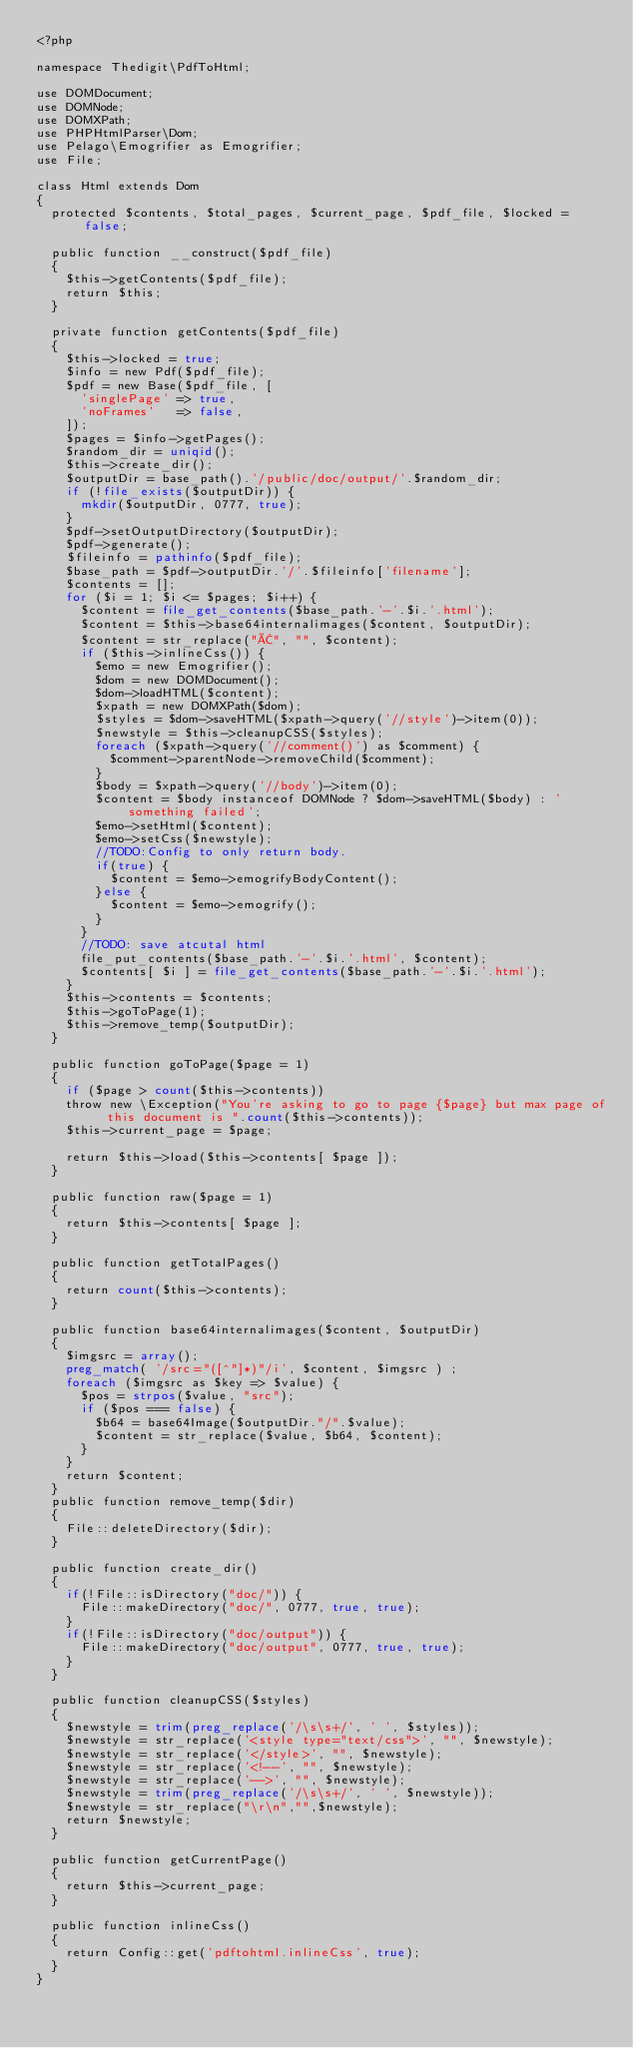<code> <loc_0><loc_0><loc_500><loc_500><_PHP_><?php

namespace Thedigit\PdfToHtml;

use DOMDocument;
use DOMNode;
use DOMXPath;
use PHPHtmlParser\Dom;
use Pelago\Emogrifier as Emogrifier;
use File;

class Html extends Dom
{
  protected $contents, $total_pages, $current_page, $pdf_file, $locked = false;

  public function __construct($pdf_file)
  {
    $this->getContents($pdf_file);
    return $this;
  }

  private function getContents($pdf_file)
  {
    $this->locked = true;
    $info = new Pdf($pdf_file);
    $pdf = new Base($pdf_file, [
      'singlePage' => true,
      'noFrames'   => false,
    ]);
    $pages = $info->getPages();
    $random_dir = uniqid();
    $this->create_dir();
    $outputDir = base_path().'/public/doc/output/'.$random_dir;
    if (!file_exists($outputDir)) {
      mkdir($outputDir, 0777, true);
    }
    $pdf->setOutputDirectory($outputDir);
    $pdf->generate();
    $fileinfo = pathinfo($pdf_file);
    $base_path = $pdf->outputDir.'/'.$fileinfo['filename'];
    $contents = [];
    for ($i = 1; $i <= $pages; $i++) {
      $content = file_get_contents($base_path.'-'.$i.'.html');
      $content = $this->base64internalimages($content, $outputDir);
      $content = str_replace("Â", "", $content);
      if ($this->inlineCss()) {
        $emo = new Emogrifier();
        $dom = new DOMDocument();
        $dom->loadHTML($content);
        $xpath = new DOMXPath($dom);
        $styles = $dom->saveHTML($xpath->query('//style')->item(0));
        $newstyle = $this->cleanupCSS($styles);
        foreach ($xpath->query('//comment()') as $comment) {
          $comment->parentNode->removeChild($comment);
        }
        $body = $xpath->query('//body')->item(0);
        $content = $body instanceof DOMNode ? $dom->saveHTML($body) : 'something failed';
        $emo->setHtml($content);
        $emo->setCss($newstyle);
        //TODO:Config to only return body.
        if(true) {
          $content = $emo->emogrifyBodyContent();
        }else {
          $content = $emo->emogrify();
        }
      }
      //TODO: save atcutal html
      file_put_contents($base_path.'-'.$i.'.html', $content);
      $contents[ $i ] = file_get_contents($base_path.'-'.$i.'.html');
    }
    $this->contents = $contents;
    $this->goToPage(1);
    $this->remove_temp($outputDir);
  }

  public function goToPage($page = 1)
  {
    if ($page > count($this->contents))
    throw new \Exception("You're asking to go to page {$page} but max page of this document is ".count($this->contents));
    $this->current_page = $page;

    return $this->load($this->contents[ $page ]);
  }

  public function raw($page = 1)
  {
    return $this->contents[ $page ];
  }

  public function getTotalPages()
  {
    return count($this->contents);
  }

  public function base64internalimages($content, $outputDir)
  {
    $imgsrc = array();
    preg_match( '/src="([^"]*)"/i', $content, $imgsrc ) ;
    foreach ($imgsrc as $key => $value) {
      $pos = strpos($value, "src");
      if ($pos === false) {
        $b64 = base64Image($outputDir."/".$value);
        $content = str_replace($value, $b64, $content);
      }
    }
    return $content;
  }
  public function remove_temp($dir)
  {
    File::deleteDirectory($dir);
  }

  public function create_dir()
  {
    if(!File::isDirectory("doc/")) {
      File::makeDirectory("doc/", 0777, true, true);
    }
    if(!File::isDirectory("doc/output")) {
      File::makeDirectory("doc/output", 0777, true, true);
    }
  }

  public function cleanupCSS($styles)
  {
    $newstyle = trim(preg_replace('/\s\s+/', ' ', $styles));
    $newstyle = str_replace('<style type="text/css">', "", $newstyle);
    $newstyle = str_replace('</style>', "", $newstyle);
    $newstyle = str_replace('<!--', "", $newstyle);
    $newstyle = str_replace('-->', "", $newstyle);
    $newstyle = trim(preg_replace('/\s\s+/', ' ', $newstyle));
    $newstyle = str_replace("\r\n","",$newstyle);
    return $newstyle;
  }

  public function getCurrentPage()
  {
    return $this->current_page;
  }

  public function inlineCss()
  {
    return Config::get('pdftohtml.inlineCss', true);
  }
}
</code> 